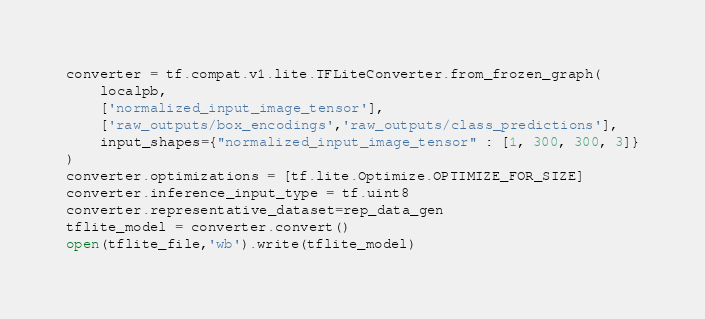<code> <loc_0><loc_0><loc_500><loc_500><_Python_>converter = tf.compat.v1.lite.TFLiteConverter.from_frozen_graph(
    localpb,
    ['normalized_input_image_tensor'],
    ['raw_outputs/box_encodings','raw_outputs/class_predictions'],
    input_shapes={"normalized_input_image_tensor" : [1, 300, 300, 3]}
)
converter.optimizations = [tf.lite.Optimize.OPTIMIZE_FOR_SIZE]
converter.inference_input_type = tf.uint8
converter.representative_dataset=rep_data_gen
tflite_model = converter.convert()
open(tflite_file,'wb').write(tflite_model)</code> 